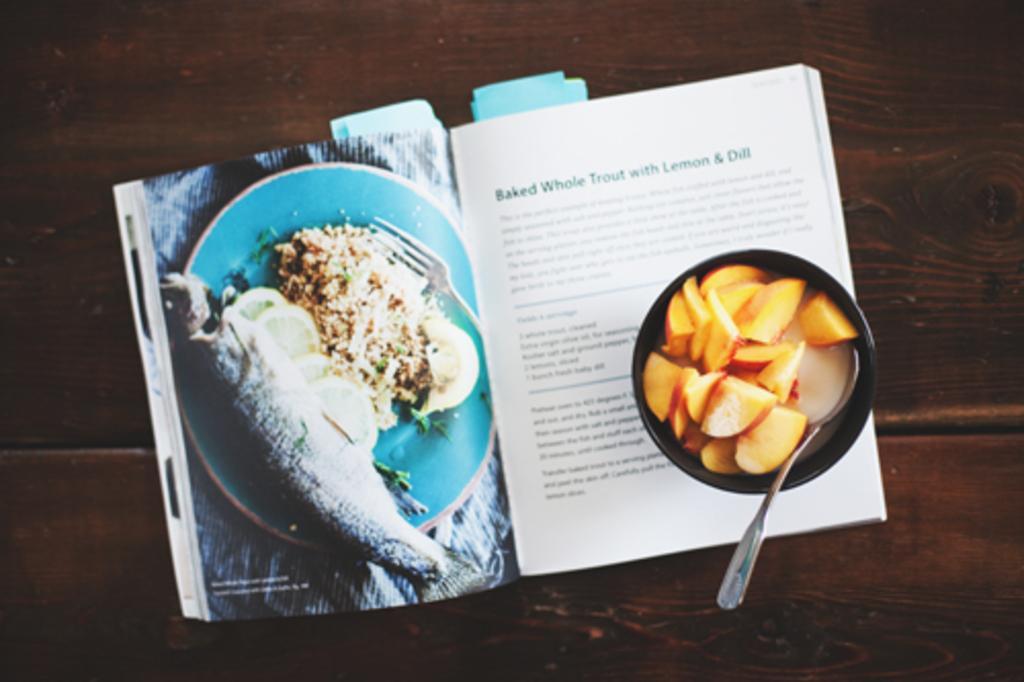Could you give a brief overview of what you see in this image? In this image we can see food in a bowl with spoon and book placed on the table. 